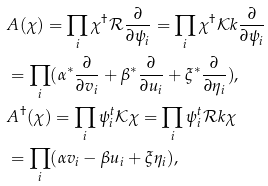Convert formula to latex. <formula><loc_0><loc_0><loc_500><loc_500>& A ( \chi ) = \prod _ { i } \chi ^ { \dagger } \mathcal { R } \frac { \partial } { \partial \psi _ { i } } = \prod _ { i } \chi ^ { \dagger } \mathcal { K } k \frac { \partial } { \partial \psi _ { i } } \\ & = \prod _ { i } ( \alpha ^ { * } \frac { \partial } { \partial v _ { i } } + \beta ^ { * } \frac { \partial } { \partial u _ { i } } + \xi ^ { * } \frac { \partial } { \partial \eta _ { i } } ) , \\ & A ^ { \dagger } ( \chi ) = \prod _ { i } \psi ^ { t } _ { i } \mathcal { K } \chi = \prod _ { i } \psi ^ { t } _ { i } \mathcal { R } k \chi \\ & = \prod _ { i } ( \alpha v _ { i } - \beta u _ { i } + \xi \eta _ { i } ) ,</formula> 